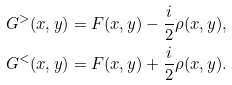<formula> <loc_0><loc_0><loc_500><loc_500>G ^ { > } ( x , y ) & = F ( x , y ) - \frac { i } { 2 } \rho ( x , y ) , \\ G ^ { < } ( x , y ) & = F ( x , y ) + \frac { i } { 2 } \rho ( x , y ) .</formula> 